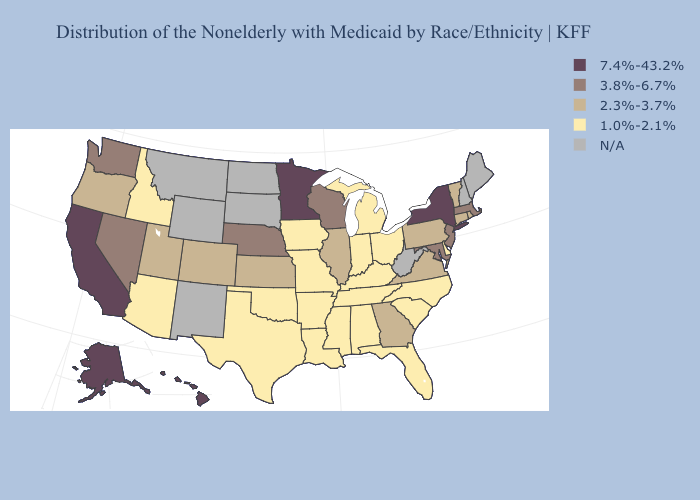Does Wisconsin have the highest value in the USA?
Keep it brief. No. Does Nebraska have the lowest value in the MidWest?
Short answer required. No. Does Arkansas have the highest value in the USA?
Answer briefly. No. What is the lowest value in the Northeast?
Answer briefly. 2.3%-3.7%. What is the value of Missouri?
Short answer required. 1.0%-2.1%. Name the states that have a value in the range 3.8%-6.7%?
Give a very brief answer. Maryland, Massachusetts, Nebraska, Nevada, New Jersey, Washington, Wisconsin. Name the states that have a value in the range 7.4%-43.2%?
Give a very brief answer. Alaska, California, Hawaii, Minnesota, New York. Which states hav the highest value in the Northeast?
Write a very short answer. New York. Which states have the lowest value in the USA?
Concise answer only. Alabama, Arizona, Arkansas, Delaware, Florida, Idaho, Indiana, Iowa, Kentucky, Louisiana, Michigan, Mississippi, Missouri, North Carolina, Ohio, Oklahoma, South Carolina, Tennessee, Texas. What is the highest value in states that border South Carolina?
Write a very short answer. 2.3%-3.7%. Does New Jersey have the lowest value in the USA?
Write a very short answer. No. What is the highest value in the Northeast ?
Answer briefly. 7.4%-43.2%. 